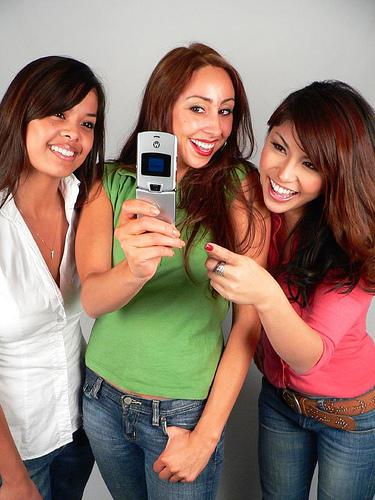Question: what is white?
Choices:
A. The curtains.
B. The cat.
C. The girls dress.
D. Shirt.
Answer with the letter. Answer: D Question: where is the lady in green?
Choices:
A. Middle.
B. On the right.
C. In the chair.
D. Standing on the stage.
Answer with the letter. Answer: A Question: what is blue?
Choices:
A. Jeans.
B. The carpet.
C. The car.
D. The sky.
Answer with the letter. Answer: A Question: why are they smiling?
Choices:
A. They are watching grandpa dance.
B. It's a birthday party.
C. The just graduated.
D. Taking a picture.
Answer with the letter. Answer: D Question: what is silver?
Choices:
A. The medal.
B. Phone.
C. The trophy.
D. The necklace.
Answer with the letter. Answer: B Question: how many ladies?
Choices:
A. Three.
B. Two.
C. One.
D. Four.
Answer with the letter. Answer: A 